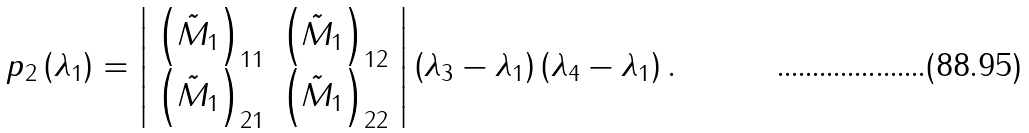<formula> <loc_0><loc_0><loc_500><loc_500>p _ { 2 } \left ( \lambda _ { 1 } \right ) = \left | \begin{array} { c c } \left ( \tilde { M } _ { 1 } \right ) _ { 1 1 } & \left ( \tilde { M } _ { 1 } \right ) _ { 1 2 } \\ \left ( \tilde { M } _ { 1 } \right ) _ { 2 1 } & \left ( \tilde { M } _ { 1 } \right ) _ { 2 2 } \end{array} \right | \left ( \lambda _ { 3 } - \lambda _ { 1 } \right ) \left ( \lambda _ { 4 } - \lambda _ { 1 } \right ) .</formula> 